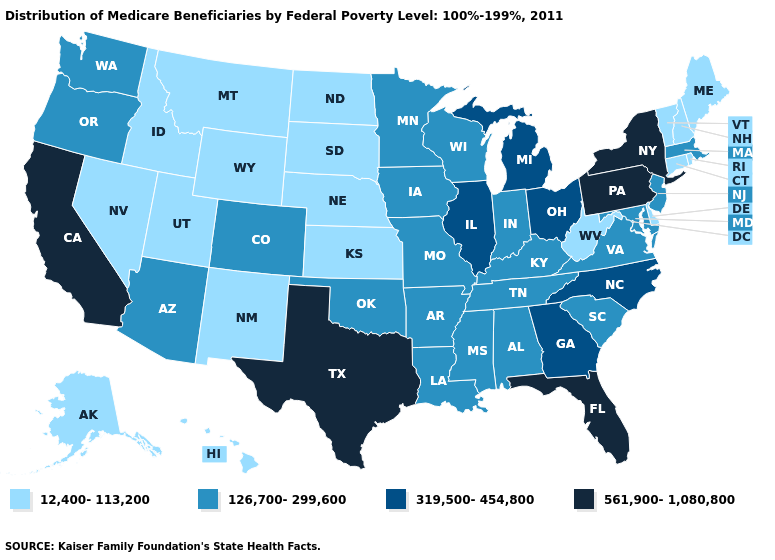Does New Jersey have the highest value in the Northeast?
Be succinct. No. Name the states that have a value in the range 126,700-299,600?
Concise answer only. Alabama, Arizona, Arkansas, Colorado, Indiana, Iowa, Kentucky, Louisiana, Maryland, Massachusetts, Minnesota, Mississippi, Missouri, New Jersey, Oklahoma, Oregon, South Carolina, Tennessee, Virginia, Washington, Wisconsin. Does Michigan have the lowest value in the MidWest?
Concise answer only. No. What is the lowest value in states that border Kansas?
Answer briefly. 12,400-113,200. Does Missouri have a lower value than Pennsylvania?
Write a very short answer. Yes. Does Idaho have the highest value in the USA?
Write a very short answer. No. Among the states that border Ohio , which have the highest value?
Be succinct. Pennsylvania. Which states hav the highest value in the West?
Answer briefly. California. Which states have the highest value in the USA?
Short answer required. California, Florida, New York, Pennsylvania, Texas. What is the value of Alabama?
Concise answer only. 126,700-299,600. What is the value of Louisiana?
Write a very short answer. 126,700-299,600. What is the lowest value in states that border West Virginia?
Give a very brief answer. 126,700-299,600. Name the states that have a value in the range 126,700-299,600?
Give a very brief answer. Alabama, Arizona, Arkansas, Colorado, Indiana, Iowa, Kentucky, Louisiana, Maryland, Massachusetts, Minnesota, Mississippi, Missouri, New Jersey, Oklahoma, Oregon, South Carolina, Tennessee, Virginia, Washington, Wisconsin. Does the map have missing data?
Keep it brief. No. What is the value of Wyoming?
Concise answer only. 12,400-113,200. 